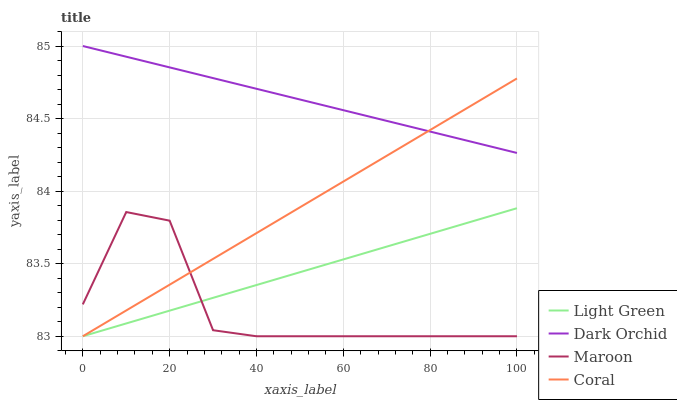Does Maroon have the minimum area under the curve?
Answer yes or no. Yes. Does Dark Orchid have the maximum area under the curve?
Answer yes or no. Yes. Does Coral have the minimum area under the curve?
Answer yes or no. No. Does Coral have the maximum area under the curve?
Answer yes or no. No. Is Dark Orchid the smoothest?
Answer yes or no. Yes. Is Maroon the roughest?
Answer yes or no. Yes. Is Coral the smoothest?
Answer yes or no. No. Is Coral the roughest?
Answer yes or no. No. Does Maroon have the lowest value?
Answer yes or no. Yes. Does Dark Orchid have the lowest value?
Answer yes or no. No. Does Dark Orchid have the highest value?
Answer yes or no. Yes. Does Coral have the highest value?
Answer yes or no. No. Is Maroon less than Dark Orchid?
Answer yes or no. Yes. Is Dark Orchid greater than Maroon?
Answer yes or no. Yes. Does Coral intersect Maroon?
Answer yes or no. Yes. Is Coral less than Maroon?
Answer yes or no. No. Is Coral greater than Maroon?
Answer yes or no. No. Does Maroon intersect Dark Orchid?
Answer yes or no. No. 